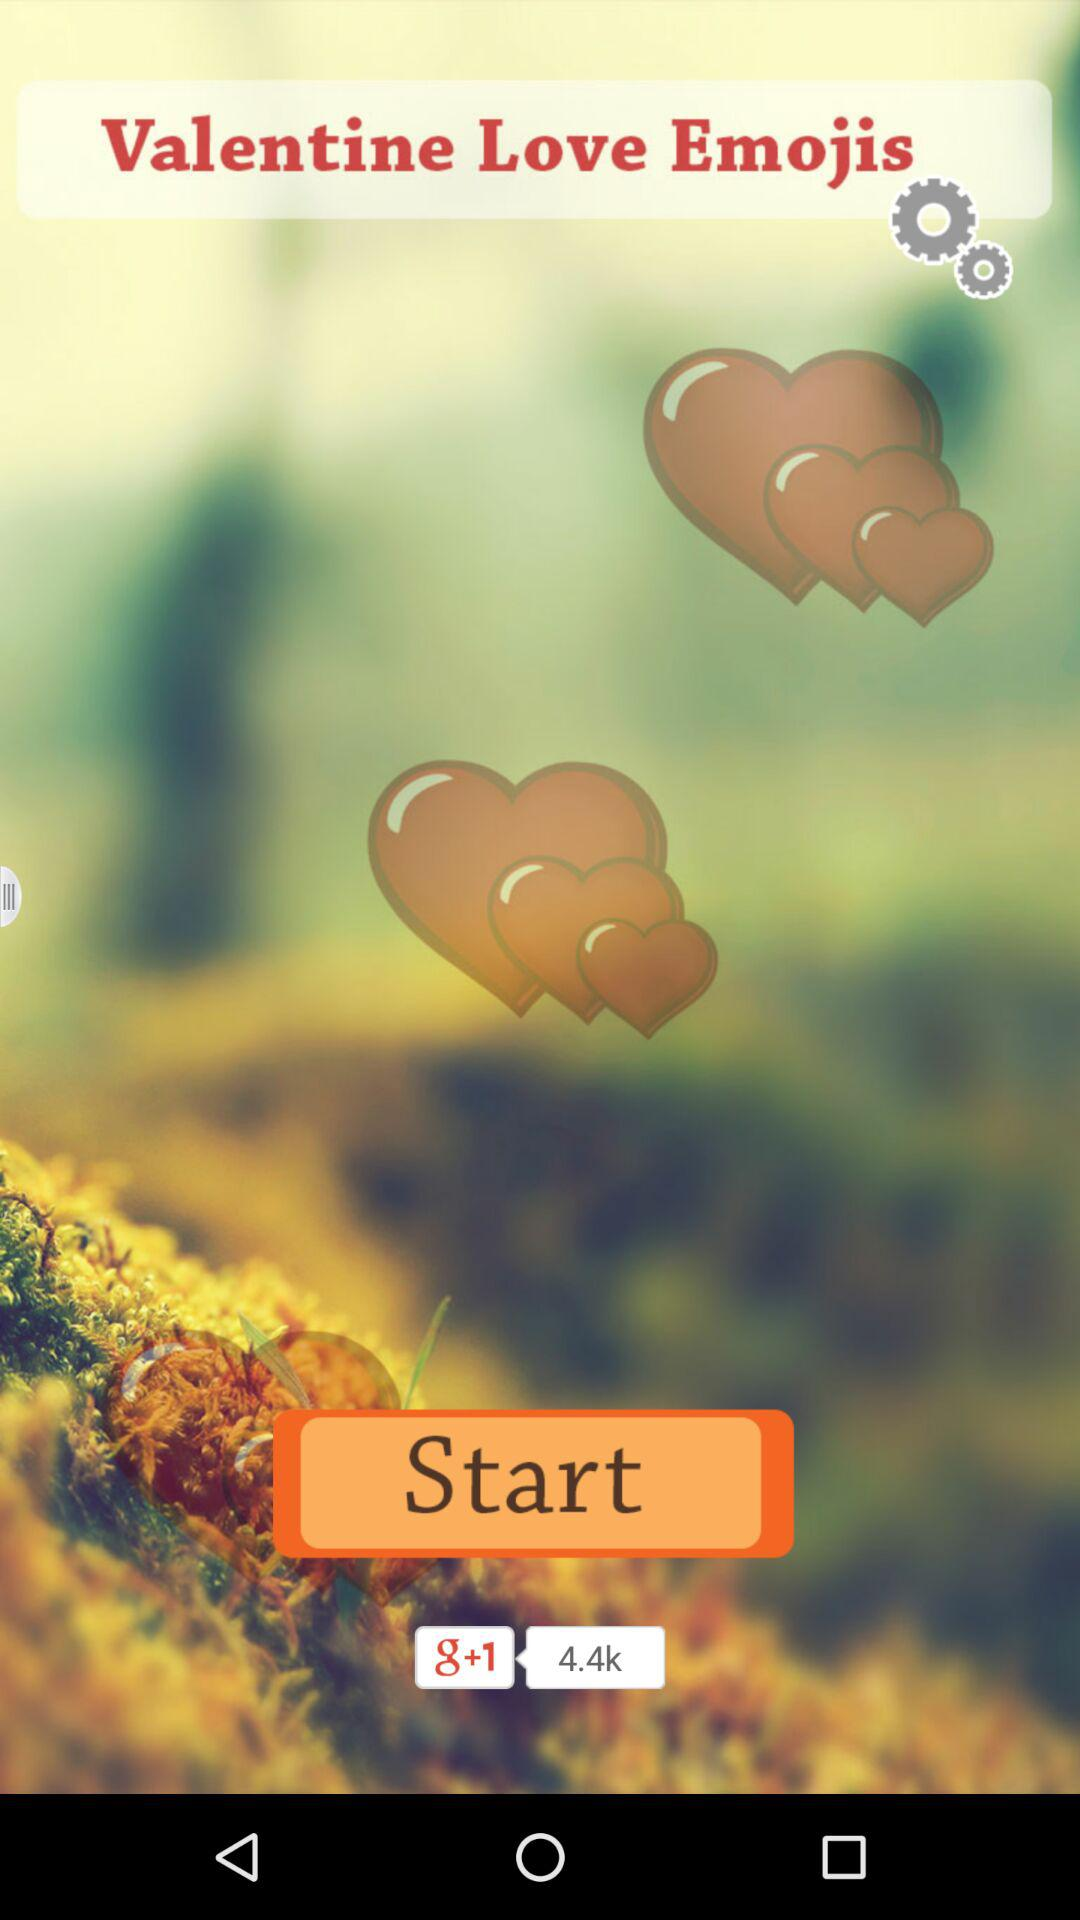How many hearts are floating in the air?
Answer the question using a single word or phrase. 6 